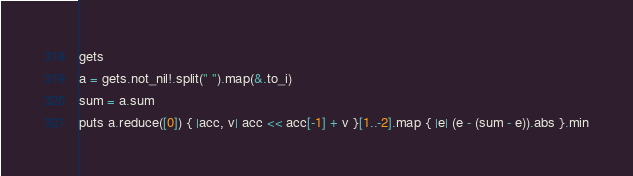<code> <loc_0><loc_0><loc_500><loc_500><_Crystal_>gets
a = gets.not_nil!.split(" ").map(&.to_i)
sum = a.sum
puts a.reduce([0]) { |acc, v| acc << acc[-1] + v }[1..-2].map { |e| (e - (sum - e)).abs }.min
</code> 